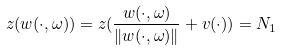<formula> <loc_0><loc_0><loc_500><loc_500>z ( w ( \cdot , \omega ) ) = z ( \frac { w ( \cdot , \omega ) } { \| w ( \cdot , \omega ) \| } + v ( \cdot ) ) = N _ { 1 }</formula> 